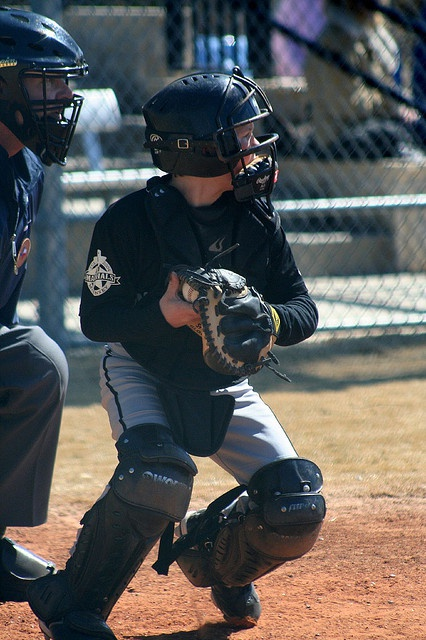Describe the objects in this image and their specific colors. I can see people in black, gray, navy, and blue tones, people in black, navy, gray, and blue tones, baseball glove in black, gray, and darkblue tones, and sports ball in black and gray tones in this image. 